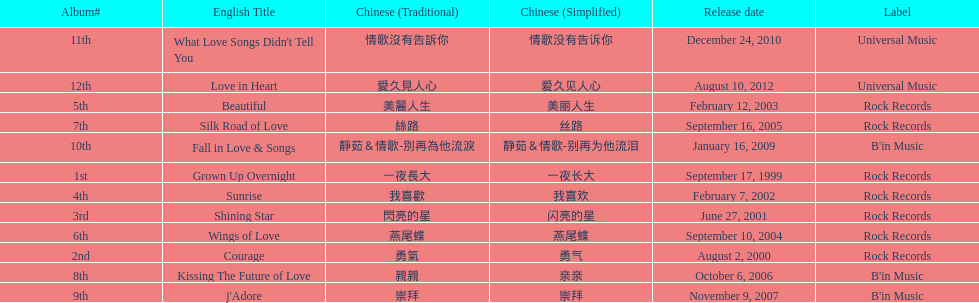Which song is listed first in the table? Grown Up Overnight. 